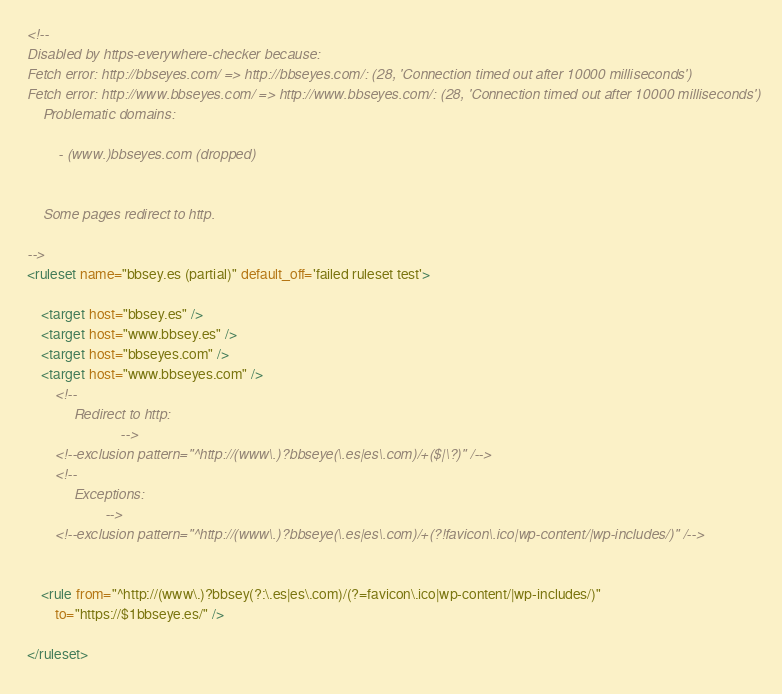<code> <loc_0><loc_0><loc_500><loc_500><_XML_><!--
Disabled by https-everywhere-checker because:
Fetch error: http://bbseyes.com/ => http://bbseyes.com/: (28, 'Connection timed out after 10000 milliseconds')
Fetch error: http://www.bbseyes.com/ => http://www.bbseyes.com/: (28, 'Connection timed out after 10000 milliseconds')
	Problematic domains:

		- (www.)bbseyes.com	(dropped)


	Some pages redirect to http.

-->
<ruleset name="bbsey.es (partial)" default_off='failed ruleset test'>

	<target host="bbsey.es" />
	<target host="www.bbsey.es" />
	<target host="bbseyes.com" />
	<target host="www.bbseyes.com" />
		<!--
			Redirect to http:
						-->
		<!--exclusion pattern="^http://(www\.)?bbseye(\.es|es\.com)/+($|\?)" /-->
		<!--
			Exceptions:
					-->
		<!--exclusion pattern="^http://(www\.)?bbseye(\.es|es\.com)/+(?!favicon\.ico|wp-content/|wp-includes/)" /-->


	<rule from="^http://(www\.)?bbsey(?:\.es|es\.com)/(?=favicon\.ico|wp-content/|wp-includes/)"
		to="https://$1bbseye.es/" />

</ruleset>
</code> 